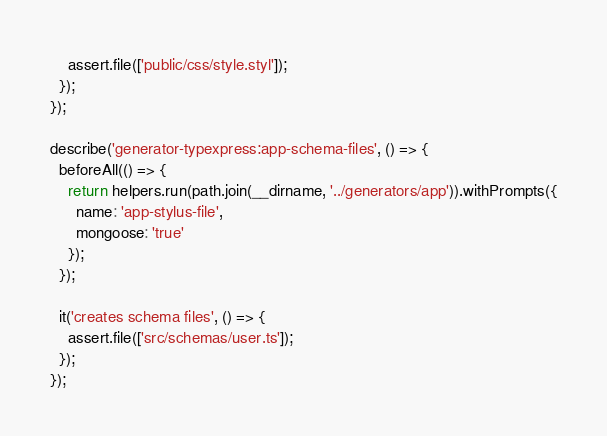Convert code to text. <code><loc_0><loc_0><loc_500><loc_500><_JavaScript_>    assert.file(['public/css/style.styl']);
  });
});

describe('generator-typexpress:app-schema-files', () => {
  beforeAll(() => {
    return helpers.run(path.join(__dirname, '../generators/app')).withPrompts({
      name: 'app-stylus-file',
      mongoose: 'true'
    });
  });

  it('creates schema files', () => {
    assert.file(['src/schemas/user.ts']);
  });
});
</code> 